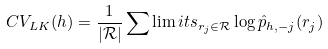Convert formula to latex. <formula><loc_0><loc_0><loc_500><loc_500>C V _ { L K } ( h ) = \frac { 1 } { | \mathcal { R } | } \sum \lim i t s _ { r _ { j } \in \mathcal { R } } \log \hat { p } _ { h , - j } ( r _ { j } )</formula> 